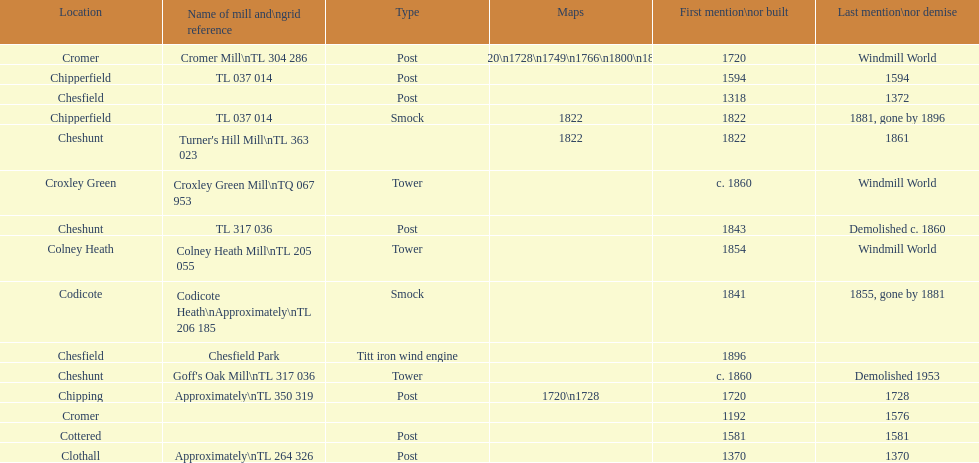Did cromer, chipperfield or cheshunt have the most windmills? Cheshunt. 